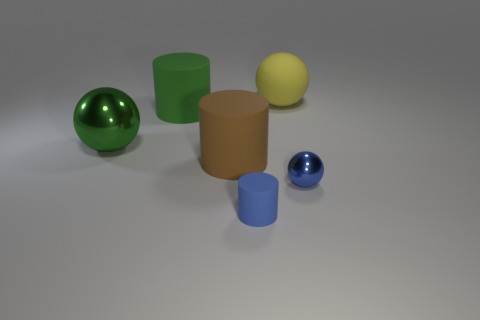There is a matte cylinder that is the same color as the small metal ball; what size is it?
Your response must be concise. Small. What is the shape of the small blue thing to the right of the rubber thing that is in front of the sphere that is to the right of the large yellow matte sphere?
Give a very brief answer. Sphere. There is a sphere that is in front of the green shiny sphere; does it have the same size as the shiny thing to the left of the yellow thing?
Provide a short and direct response. No. What number of large green cylinders have the same material as the tiny cylinder?
Keep it short and to the point. 1. How many tiny metallic spheres are on the right side of the metal ball behind the large thing in front of the green ball?
Offer a very short reply. 1. Do the large yellow matte object and the brown matte thing have the same shape?
Your response must be concise. No. Is there a yellow object of the same shape as the big green shiny thing?
Ensure brevity in your answer.  Yes. There is a green metallic thing that is the same size as the yellow matte thing; what is its shape?
Your answer should be very brief. Sphere. There is a sphere that is in front of the large matte cylinder in front of the large green object behind the big metallic ball; what is it made of?
Your answer should be very brief. Metal. Do the green ball and the brown cylinder have the same size?
Ensure brevity in your answer.  Yes. 